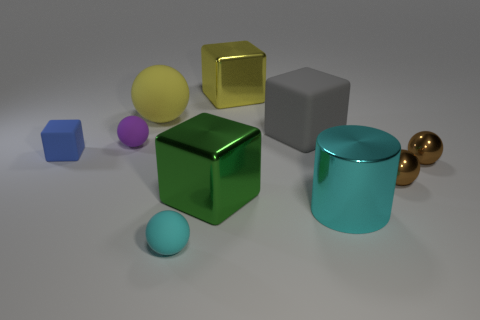Subtract 1 blocks. How many blocks are left? 3 Subtract all small cyan balls. How many balls are left? 4 Subtract all red spheres. Subtract all cyan blocks. How many spheres are left? 5 Subtract all blocks. How many objects are left? 6 Add 5 small red spheres. How many small red spheres exist? 5 Subtract 0 cyan cubes. How many objects are left? 10 Subtract all large yellow metallic blocks. Subtract all tiny cyan objects. How many objects are left? 8 Add 3 tiny blue matte cubes. How many tiny blue matte cubes are left? 4 